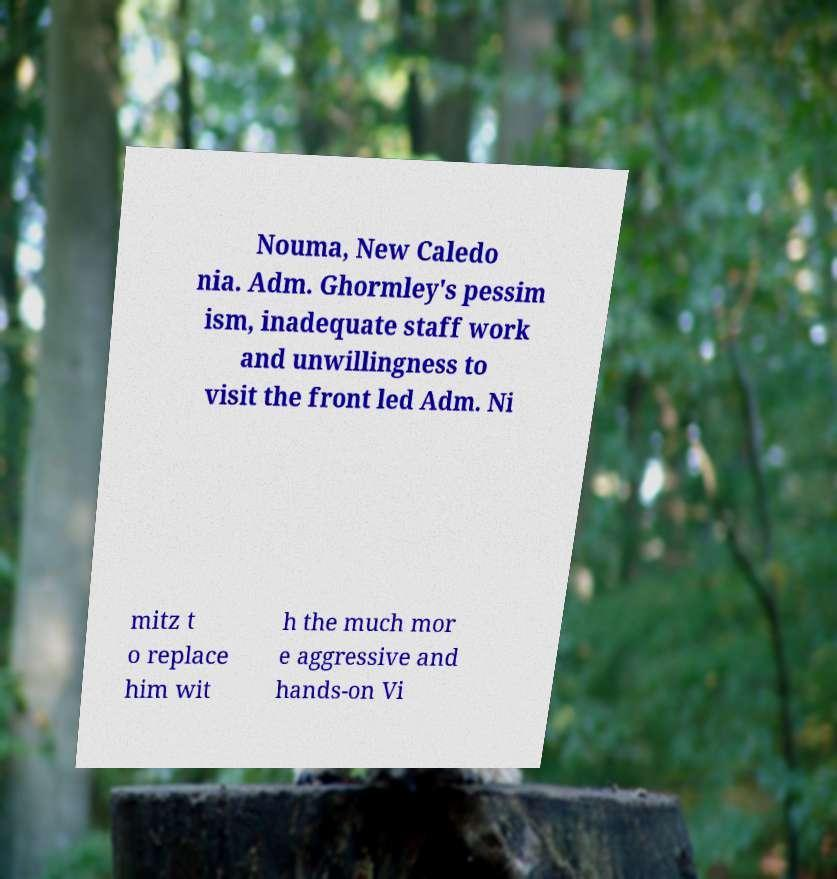Can you accurately transcribe the text from the provided image for me? Nouma, New Caledo nia. Adm. Ghormley's pessim ism, inadequate staff work and unwillingness to visit the front led Adm. Ni mitz t o replace him wit h the much mor e aggressive and hands-on Vi 